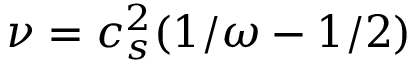Convert formula to latex. <formula><loc_0><loc_0><loc_500><loc_500>\nu = c _ { s } ^ { 2 } ( 1 / \omega - 1 / 2 )</formula> 